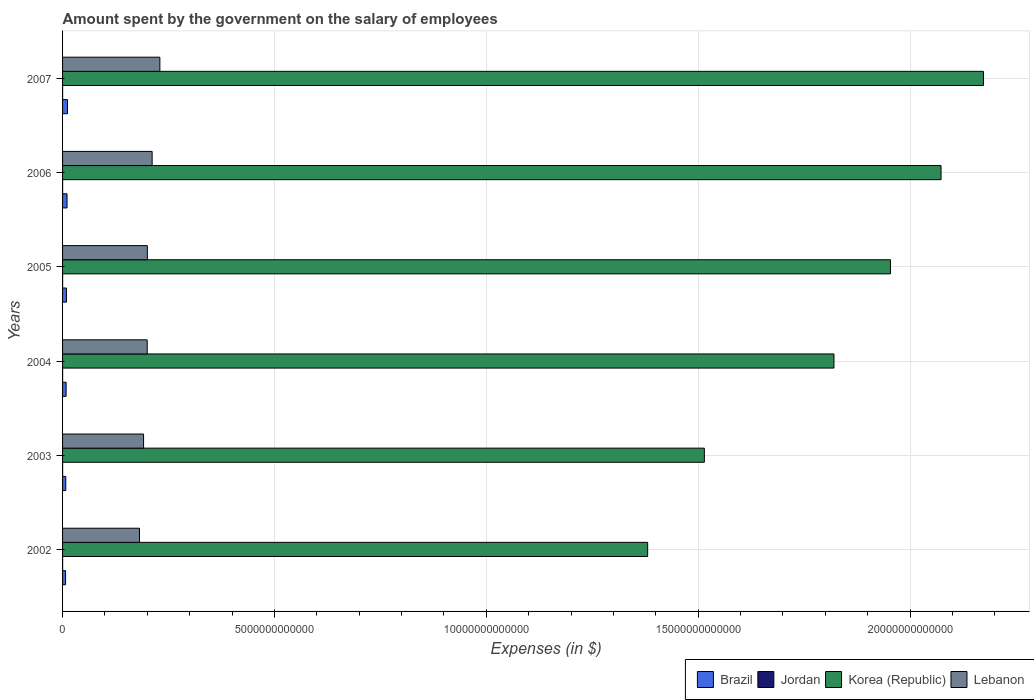How many different coloured bars are there?
Provide a short and direct response. 4. How many groups of bars are there?
Keep it short and to the point. 6. Are the number of bars on each tick of the Y-axis equal?
Your response must be concise. Yes. How many bars are there on the 6th tick from the top?
Offer a very short reply. 4. How many bars are there on the 2nd tick from the bottom?
Offer a very short reply. 4. In how many cases, is the number of bars for a given year not equal to the number of legend labels?
Provide a short and direct response. 0. What is the amount spent on the salary of employees by the government in Korea (Republic) in 2007?
Your answer should be compact. 2.17e+13. Across all years, what is the maximum amount spent on the salary of employees by the government in Korea (Republic)?
Give a very brief answer. 2.17e+13. Across all years, what is the minimum amount spent on the salary of employees by the government in Jordan?
Make the answer very short. 1.07e+09. In which year was the amount spent on the salary of employees by the government in Brazil maximum?
Your answer should be very brief. 2007. What is the total amount spent on the salary of employees by the government in Brazil in the graph?
Offer a very short reply. 5.45e+11. What is the difference between the amount spent on the salary of employees by the government in Jordan in 2002 and that in 2007?
Provide a succinct answer. 2.23e+08. What is the difference between the amount spent on the salary of employees by the government in Korea (Republic) in 2005 and the amount spent on the salary of employees by the government in Lebanon in 2002?
Give a very brief answer. 1.77e+13. What is the average amount spent on the salary of employees by the government in Jordan per year?
Your response must be concise. 1.32e+09. In the year 2003, what is the difference between the amount spent on the salary of employees by the government in Jordan and amount spent on the salary of employees by the government in Korea (Republic)?
Provide a succinct answer. -1.51e+13. In how many years, is the amount spent on the salary of employees by the government in Brazil greater than 19000000000000 $?
Offer a terse response. 0. What is the ratio of the amount spent on the salary of employees by the government in Korea (Republic) in 2002 to that in 2003?
Give a very brief answer. 0.91. Is the difference between the amount spent on the salary of employees by the government in Jordan in 2003 and 2007 greater than the difference between the amount spent on the salary of employees by the government in Korea (Republic) in 2003 and 2007?
Provide a succinct answer. Yes. What is the difference between the highest and the second highest amount spent on the salary of employees by the government in Lebanon?
Offer a terse response. 1.83e+11. What is the difference between the highest and the lowest amount spent on the salary of employees by the government in Jordan?
Provide a succinct answer. 4.33e+08. Is the sum of the amount spent on the salary of employees by the government in Lebanon in 2003 and 2005 greater than the maximum amount spent on the salary of employees by the government in Korea (Republic) across all years?
Make the answer very short. No. What does the 4th bar from the bottom in 2002 represents?
Ensure brevity in your answer.  Lebanon. How many bars are there?
Make the answer very short. 24. Are all the bars in the graph horizontal?
Keep it short and to the point. Yes. What is the difference between two consecutive major ticks on the X-axis?
Your response must be concise. 5.00e+12. Are the values on the major ticks of X-axis written in scientific E-notation?
Make the answer very short. No. How are the legend labels stacked?
Ensure brevity in your answer.  Horizontal. What is the title of the graph?
Your response must be concise. Amount spent by the government on the salary of employees. Does "World" appear as one of the legend labels in the graph?
Keep it short and to the point. No. What is the label or title of the X-axis?
Give a very brief answer. Expenses (in $). What is the label or title of the Y-axis?
Offer a terse response. Years. What is the Expenses (in $) in Brazil in 2002?
Provide a short and direct response. 7.11e+1. What is the Expenses (in $) of Jordan in 2002?
Your answer should be very brief. 1.29e+09. What is the Expenses (in $) in Korea (Republic) in 2002?
Provide a short and direct response. 1.38e+13. What is the Expenses (in $) in Lebanon in 2002?
Your answer should be compact. 1.82e+12. What is the Expenses (in $) of Brazil in 2003?
Make the answer very short. 7.58e+1. What is the Expenses (in $) in Jordan in 2003?
Your answer should be compact. 1.44e+09. What is the Expenses (in $) in Korea (Republic) in 2003?
Ensure brevity in your answer.  1.51e+13. What is the Expenses (in $) of Lebanon in 2003?
Offer a terse response. 1.91e+12. What is the Expenses (in $) in Brazil in 2004?
Keep it short and to the point. 8.37e+1. What is the Expenses (in $) of Jordan in 2004?
Give a very brief answer. 1.50e+09. What is the Expenses (in $) of Korea (Republic) in 2004?
Make the answer very short. 1.82e+13. What is the Expenses (in $) of Lebanon in 2004?
Offer a very short reply. 2.00e+12. What is the Expenses (in $) of Brazil in 2005?
Make the answer very short. 9.22e+1. What is the Expenses (in $) in Jordan in 2005?
Ensure brevity in your answer.  1.25e+09. What is the Expenses (in $) in Korea (Republic) in 2005?
Offer a very short reply. 1.95e+13. What is the Expenses (in $) in Lebanon in 2005?
Offer a very short reply. 2.00e+12. What is the Expenses (in $) in Brazil in 2006?
Keep it short and to the point. 1.05e+11. What is the Expenses (in $) in Jordan in 2006?
Provide a short and direct response. 1.38e+09. What is the Expenses (in $) of Korea (Republic) in 2006?
Offer a very short reply. 2.07e+13. What is the Expenses (in $) of Lebanon in 2006?
Provide a short and direct response. 2.11e+12. What is the Expenses (in $) in Brazil in 2007?
Offer a very short reply. 1.16e+11. What is the Expenses (in $) in Jordan in 2007?
Your answer should be compact. 1.07e+09. What is the Expenses (in $) of Korea (Republic) in 2007?
Provide a short and direct response. 2.17e+13. What is the Expenses (in $) of Lebanon in 2007?
Give a very brief answer. 2.30e+12. Across all years, what is the maximum Expenses (in $) of Brazil?
Offer a terse response. 1.16e+11. Across all years, what is the maximum Expenses (in $) of Jordan?
Ensure brevity in your answer.  1.50e+09. Across all years, what is the maximum Expenses (in $) of Korea (Republic)?
Provide a short and direct response. 2.17e+13. Across all years, what is the maximum Expenses (in $) of Lebanon?
Offer a very short reply. 2.30e+12. Across all years, what is the minimum Expenses (in $) of Brazil?
Give a very brief answer. 7.11e+1. Across all years, what is the minimum Expenses (in $) in Jordan?
Your answer should be compact. 1.07e+09. Across all years, what is the minimum Expenses (in $) in Korea (Republic)?
Your answer should be compact. 1.38e+13. Across all years, what is the minimum Expenses (in $) in Lebanon?
Offer a very short reply. 1.82e+12. What is the total Expenses (in $) in Brazil in the graph?
Give a very brief answer. 5.45e+11. What is the total Expenses (in $) of Jordan in the graph?
Your answer should be very brief. 7.93e+09. What is the total Expenses (in $) in Korea (Republic) in the graph?
Provide a short and direct response. 1.09e+14. What is the total Expenses (in $) of Lebanon in the graph?
Your response must be concise. 1.21e+13. What is the difference between the Expenses (in $) in Brazil in 2002 and that in 2003?
Offer a very short reply. -4.75e+09. What is the difference between the Expenses (in $) of Jordan in 2002 and that in 2003?
Make the answer very short. -1.46e+08. What is the difference between the Expenses (in $) in Korea (Republic) in 2002 and that in 2003?
Offer a very short reply. -1.34e+12. What is the difference between the Expenses (in $) in Lebanon in 2002 and that in 2003?
Offer a very short reply. -9.67e+1. What is the difference between the Expenses (in $) in Brazil in 2002 and that in 2004?
Ensure brevity in your answer.  -1.26e+1. What is the difference between the Expenses (in $) of Jordan in 2002 and that in 2004?
Your answer should be compact. -2.10e+08. What is the difference between the Expenses (in $) of Korea (Republic) in 2002 and that in 2004?
Your answer should be compact. -4.40e+12. What is the difference between the Expenses (in $) of Lebanon in 2002 and that in 2004?
Ensure brevity in your answer.  -1.82e+11. What is the difference between the Expenses (in $) in Brazil in 2002 and that in 2005?
Provide a succinct answer. -2.11e+1. What is the difference between the Expenses (in $) of Jordan in 2002 and that in 2005?
Provide a succinct answer. 3.66e+07. What is the difference between the Expenses (in $) in Korea (Republic) in 2002 and that in 2005?
Offer a terse response. -5.73e+12. What is the difference between the Expenses (in $) of Lebanon in 2002 and that in 2005?
Ensure brevity in your answer.  -1.86e+11. What is the difference between the Expenses (in $) of Brazil in 2002 and that in 2006?
Your answer should be very brief. -3.44e+1. What is the difference between the Expenses (in $) in Jordan in 2002 and that in 2006?
Ensure brevity in your answer.  -9.21e+07. What is the difference between the Expenses (in $) of Korea (Republic) in 2002 and that in 2006?
Provide a succinct answer. -6.92e+12. What is the difference between the Expenses (in $) in Lebanon in 2002 and that in 2006?
Your answer should be very brief. -2.99e+11. What is the difference between the Expenses (in $) in Brazil in 2002 and that in 2007?
Ensure brevity in your answer.  -4.53e+1. What is the difference between the Expenses (in $) in Jordan in 2002 and that in 2007?
Your response must be concise. 2.23e+08. What is the difference between the Expenses (in $) of Korea (Republic) in 2002 and that in 2007?
Your answer should be compact. -7.92e+12. What is the difference between the Expenses (in $) of Lebanon in 2002 and that in 2007?
Your response must be concise. -4.81e+11. What is the difference between the Expenses (in $) of Brazil in 2003 and that in 2004?
Offer a very short reply. -7.81e+09. What is the difference between the Expenses (in $) in Jordan in 2003 and that in 2004?
Your response must be concise. -6.46e+07. What is the difference between the Expenses (in $) of Korea (Republic) in 2003 and that in 2004?
Keep it short and to the point. -3.06e+12. What is the difference between the Expenses (in $) in Lebanon in 2003 and that in 2004?
Offer a terse response. -8.57e+1. What is the difference between the Expenses (in $) of Brazil in 2003 and that in 2005?
Provide a short and direct response. -1.64e+1. What is the difference between the Expenses (in $) in Jordan in 2003 and that in 2005?
Give a very brief answer. 1.82e+08. What is the difference between the Expenses (in $) in Korea (Republic) in 2003 and that in 2005?
Make the answer very short. -4.39e+12. What is the difference between the Expenses (in $) in Lebanon in 2003 and that in 2005?
Keep it short and to the point. -8.92e+1. What is the difference between the Expenses (in $) in Brazil in 2003 and that in 2006?
Ensure brevity in your answer.  -2.97e+1. What is the difference between the Expenses (in $) in Jordan in 2003 and that in 2006?
Ensure brevity in your answer.  5.34e+07. What is the difference between the Expenses (in $) of Korea (Republic) in 2003 and that in 2006?
Keep it short and to the point. -5.59e+12. What is the difference between the Expenses (in $) of Lebanon in 2003 and that in 2006?
Your answer should be compact. -2.02e+11. What is the difference between the Expenses (in $) in Brazil in 2003 and that in 2007?
Your answer should be compact. -4.05e+1. What is the difference between the Expenses (in $) in Jordan in 2003 and that in 2007?
Provide a short and direct response. 3.69e+08. What is the difference between the Expenses (in $) in Korea (Republic) in 2003 and that in 2007?
Keep it short and to the point. -6.59e+12. What is the difference between the Expenses (in $) of Lebanon in 2003 and that in 2007?
Provide a short and direct response. -3.85e+11. What is the difference between the Expenses (in $) of Brazil in 2004 and that in 2005?
Keep it short and to the point. -8.57e+09. What is the difference between the Expenses (in $) of Jordan in 2004 and that in 2005?
Make the answer very short. 2.47e+08. What is the difference between the Expenses (in $) in Korea (Republic) in 2004 and that in 2005?
Your answer should be compact. -1.33e+12. What is the difference between the Expenses (in $) in Lebanon in 2004 and that in 2005?
Your answer should be compact. -3.43e+09. What is the difference between the Expenses (in $) of Brazil in 2004 and that in 2006?
Your answer should be very brief. -2.18e+1. What is the difference between the Expenses (in $) in Jordan in 2004 and that in 2006?
Offer a very short reply. 1.18e+08. What is the difference between the Expenses (in $) of Korea (Republic) in 2004 and that in 2006?
Offer a very short reply. -2.53e+12. What is the difference between the Expenses (in $) of Lebanon in 2004 and that in 2006?
Ensure brevity in your answer.  -1.16e+11. What is the difference between the Expenses (in $) in Brazil in 2004 and that in 2007?
Your answer should be very brief. -3.27e+1. What is the difference between the Expenses (in $) in Jordan in 2004 and that in 2007?
Ensure brevity in your answer.  4.33e+08. What is the difference between the Expenses (in $) in Korea (Republic) in 2004 and that in 2007?
Ensure brevity in your answer.  -3.53e+12. What is the difference between the Expenses (in $) in Lebanon in 2004 and that in 2007?
Ensure brevity in your answer.  -2.99e+11. What is the difference between the Expenses (in $) of Brazil in 2005 and that in 2006?
Your answer should be compact. -1.33e+1. What is the difference between the Expenses (in $) in Jordan in 2005 and that in 2006?
Your response must be concise. -1.29e+08. What is the difference between the Expenses (in $) of Korea (Republic) in 2005 and that in 2006?
Offer a very short reply. -1.19e+12. What is the difference between the Expenses (in $) in Lebanon in 2005 and that in 2006?
Make the answer very short. -1.13e+11. What is the difference between the Expenses (in $) of Brazil in 2005 and that in 2007?
Offer a very short reply. -2.41e+1. What is the difference between the Expenses (in $) in Jordan in 2005 and that in 2007?
Your answer should be compact. 1.86e+08. What is the difference between the Expenses (in $) of Korea (Republic) in 2005 and that in 2007?
Your response must be concise. -2.19e+12. What is the difference between the Expenses (in $) of Lebanon in 2005 and that in 2007?
Your answer should be compact. -2.96e+11. What is the difference between the Expenses (in $) of Brazil in 2006 and that in 2007?
Make the answer very short. -1.09e+1. What is the difference between the Expenses (in $) in Jordan in 2006 and that in 2007?
Give a very brief answer. 3.15e+08. What is the difference between the Expenses (in $) of Korea (Republic) in 2006 and that in 2007?
Provide a succinct answer. -1.00e+12. What is the difference between the Expenses (in $) of Lebanon in 2006 and that in 2007?
Keep it short and to the point. -1.83e+11. What is the difference between the Expenses (in $) of Brazil in 2002 and the Expenses (in $) of Jordan in 2003?
Provide a succinct answer. 6.97e+1. What is the difference between the Expenses (in $) in Brazil in 2002 and the Expenses (in $) in Korea (Republic) in 2003?
Make the answer very short. -1.51e+13. What is the difference between the Expenses (in $) in Brazil in 2002 and the Expenses (in $) in Lebanon in 2003?
Offer a very short reply. -1.84e+12. What is the difference between the Expenses (in $) in Jordan in 2002 and the Expenses (in $) in Korea (Republic) in 2003?
Your answer should be compact. -1.51e+13. What is the difference between the Expenses (in $) of Jordan in 2002 and the Expenses (in $) of Lebanon in 2003?
Give a very brief answer. -1.91e+12. What is the difference between the Expenses (in $) in Korea (Republic) in 2002 and the Expenses (in $) in Lebanon in 2003?
Provide a succinct answer. 1.19e+13. What is the difference between the Expenses (in $) in Brazil in 2002 and the Expenses (in $) in Jordan in 2004?
Make the answer very short. 6.96e+1. What is the difference between the Expenses (in $) in Brazil in 2002 and the Expenses (in $) in Korea (Republic) in 2004?
Give a very brief answer. -1.81e+13. What is the difference between the Expenses (in $) in Brazil in 2002 and the Expenses (in $) in Lebanon in 2004?
Your answer should be very brief. -1.93e+12. What is the difference between the Expenses (in $) in Jordan in 2002 and the Expenses (in $) in Korea (Republic) in 2004?
Make the answer very short. -1.82e+13. What is the difference between the Expenses (in $) of Jordan in 2002 and the Expenses (in $) of Lebanon in 2004?
Offer a very short reply. -2.00e+12. What is the difference between the Expenses (in $) in Korea (Republic) in 2002 and the Expenses (in $) in Lebanon in 2004?
Offer a very short reply. 1.18e+13. What is the difference between the Expenses (in $) of Brazil in 2002 and the Expenses (in $) of Jordan in 2005?
Make the answer very short. 6.98e+1. What is the difference between the Expenses (in $) in Brazil in 2002 and the Expenses (in $) in Korea (Republic) in 2005?
Your response must be concise. -1.95e+13. What is the difference between the Expenses (in $) in Brazil in 2002 and the Expenses (in $) in Lebanon in 2005?
Make the answer very short. -1.93e+12. What is the difference between the Expenses (in $) of Jordan in 2002 and the Expenses (in $) of Korea (Republic) in 2005?
Provide a succinct answer. -1.95e+13. What is the difference between the Expenses (in $) in Jordan in 2002 and the Expenses (in $) in Lebanon in 2005?
Ensure brevity in your answer.  -2.00e+12. What is the difference between the Expenses (in $) of Korea (Republic) in 2002 and the Expenses (in $) of Lebanon in 2005?
Provide a short and direct response. 1.18e+13. What is the difference between the Expenses (in $) of Brazil in 2002 and the Expenses (in $) of Jordan in 2006?
Your answer should be very brief. 6.97e+1. What is the difference between the Expenses (in $) of Brazil in 2002 and the Expenses (in $) of Korea (Republic) in 2006?
Offer a very short reply. -2.07e+13. What is the difference between the Expenses (in $) of Brazil in 2002 and the Expenses (in $) of Lebanon in 2006?
Your answer should be very brief. -2.04e+12. What is the difference between the Expenses (in $) in Jordan in 2002 and the Expenses (in $) in Korea (Republic) in 2006?
Provide a short and direct response. -2.07e+13. What is the difference between the Expenses (in $) in Jordan in 2002 and the Expenses (in $) in Lebanon in 2006?
Provide a short and direct response. -2.11e+12. What is the difference between the Expenses (in $) in Korea (Republic) in 2002 and the Expenses (in $) in Lebanon in 2006?
Your answer should be very brief. 1.17e+13. What is the difference between the Expenses (in $) in Brazil in 2002 and the Expenses (in $) in Jordan in 2007?
Provide a succinct answer. 7.00e+1. What is the difference between the Expenses (in $) of Brazil in 2002 and the Expenses (in $) of Korea (Republic) in 2007?
Ensure brevity in your answer.  -2.17e+13. What is the difference between the Expenses (in $) of Brazil in 2002 and the Expenses (in $) of Lebanon in 2007?
Your answer should be compact. -2.23e+12. What is the difference between the Expenses (in $) of Jordan in 2002 and the Expenses (in $) of Korea (Republic) in 2007?
Your response must be concise. -2.17e+13. What is the difference between the Expenses (in $) in Jordan in 2002 and the Expenses (in $) in Lebanon in 2007?
Your response must be concise. -2.30e+12. What is the difference between the Expenses (in $) in Korea (Republic) in 2002 and the Expenses (in $) in Lebanon in 2007?
Ensure brevity in your answer.  1.15e+13. What is the difference between the Expenses (in $) of Brazil in 2003 and the Expenses (in $) of Jordan in 2004?
Give a very brief answer. 7.43e+1. What is the difference between the Expenses (in $) of Brazil in 2003 and the Expenses (in $) of Korea (Republic) in 2004?
Provide a succinct answer. -1.81e+13. What is the difference between the Expenses (in $) in Brazil in 2003 and the Expenses (in $) in Lebanon in 2004?
Give a very brief answer. -1.92e+12. What is the difference between the Expenses (in $) in Jordan in 2003 and the Expenses (in $) in Korea (Republic) in 2004?
Your answer should be compact. -1.82e+13. What is the difference between the Expenses (in $) of Jordan in 2003 and the Expenses (in $) of Lebanon in 2004?
Provide a succinct answer. -2.00e+12. What is the difference between the Expenses (in $) of Korea (Republic) in 2003 and the Expenses (in $) of Lebanon in 2004?
Offer a very short reply. 1.31e+13. What is the difference between the Expenses (in $) in Brazil in 2003 and the Expenses (in $) in Jordan in 2005?
Your response must be concise. 7.46e+1. What is the difference between the Expenses (in $) of Brazil in 2003 and the Expenses (in $) of Korea (Republic) in 2005?
Offer a very short reply. -1.95e+13. What is the difference between the Expenses (in $) in Brazil in 2003 and the Expenses (in $) in Lebanon in 2005?
Give a very brief answer. -1.93e+12. What is the difference between the Expenses (in $) of Jordan in 2003 and the Expenses (in $) of Korea (Republic) in 2005?
Offer a very short reply. -1.95e+13. What is the difference between the Expenses (in $) in Jordan in 2003 and the Expenses (in $) in Lebanon in 2005?
Your response must be concise. -2.00e+12. What is the difference between the Expenses (in $) of Korea (Republic) in 2003 and the Expenses (in $) of Lebanon in 2005?
Your response must be concise. 1.31e+13. What is the difference between the Expenses (in $) of Brazil in 2003 and the Expenses (in $) of Jordan in 2006?
Your answer should be compact. 7.45e+1. What is the difference between the Expenses (in $) in Brazil in 2003 and the Expenses (in $) in Korea (Republic) in 2006?
Provide a short and direct response. -2.07e+13. What is the difference between the Expenses (in $) in Brazil in 2003 and the Expenses (in $) in Lebanon in 2006?
Give a very brief answer. -2.04e+12. What is the difference between the Expenses (in $) in Jordan in 2003 and the Expenses (in $) in Korea (Republic) in 2006?
Your answer should be compact. -2.07e+13. What is the difference between the Expenses (in $) of Jordan in 2003 and the Expenses (in $) of Lebanon in 2006?
Make the answer very short. -2.11e+12. What is the difference between the Expenses (in $) of Korea (Republic) in 2003 and the Expenses (in $) of Lebanon in 2006?
Offer a very short reply. 1.30e+13. What is the difference between the Expenses (in $) of Brazil in 2003 and the Expenses (in $) of Jordan in 2007?
Your response must be concise. 7.48e+1. What is the difference between the Expenses (in $) in Brazil in 2003 and the Expenses (in $) in Korea (Republic) in 2007?
Your answer should be very brief. -2.17e+13. What is the difference between the Expenses (in $) in Brazil in 2003 and the Expenses (in $) in Lebanon in 2007?
Offer a very short reply. -2.22e+12. What is the difference between the Expenses (in $) in Jordan in 2003 and the Expenses (in $) in Korea (Republic) in 2007?
Give a very brief answer. -2.17e+13. What is the difference between the Expenses (in $) of Jordan in 2003 and the Expenses (in $) of Lebanon in 2007?
Provide a succinct answer. -2.30e+12. What is the difference between the Expenses (in $) of Korea (Republic) in 2003 and the Expenses (in $) of Lebanon in 2007?
Ensure brevity in your answer.  1.28e+13. What is the difference between the Expenses (in $) of Brazil in 2004 and the Expenses (in $) of Jordan in 2005?
Offer a very short reply. 8.24e+1. What is the difference between the Expenses (in $) of Brazil in 2004 and the Expenses (in $) of Korea (Republic) in 2005?
Your answer should be compact. -1.95e+13. What is the difference between the Expenses (in $) of Brazil in 2004 and the Expenses (in $) of Lebanon in 2005?
Keep it short and to the point. -1.92e+12. What is the difference between the Expenses (in $) of Jordan in 2004 and the Expenses (in $) of Korea (Republic) in 2005?
Ensure brevity in your answer.  -1.95e+13. What is the difference between the Expenses (in $) of Jordan in 2004 and the Expenses (in $) of Lebanon in 2005?
Your answer should be compact. -2.00e+12. What is the difference between the Expenses (in $) of Korea (Republic) in 2004 and the Expenses (in $) of Lebanon in 2005?
Your response must be concise. 1.62e+13. What is the difference between the Expenses (in $) of Brazil in 2004 and the Expenses (in $) of Jordan in 2006?
Give a very brief answer. 8.23e+1. What is the difference between the Expenses (in $) of Brazil in 2004 and the Expenses (in $) of Korea (Republic) in 2006?
Your response must be concise. -2.06e+13. What is the difference between the Expenses (in $) in Brazil in 2004 and the Expenses (in $) in Lebanon in 2006?
Your answer should be compact. -2.03e+12. What is the difference between the Expenses (in $) of Jordan in 2004 and the Expenses (in $) of Korea (Republic) in 2006?
Ensure brevity in your answer.  -2.07e+13. What is the difference between the Expenses (in $) in Jordan in 2004 and the Expenses (in $) in Lebanon in 2006?
Offer a terse response. -2.11e+12. What is the difference between the Expenses (in $) in Korea (Republic) in 2004 and the Expenses (in $) in Lebanon in 2006?
Offer a terse response. 1.61e+13. What is the difference between the Expenses (in $) of Brazil in 2004 and the Expenses (in $) of Jordan in 2007?
Your response must be concise. 8.26e+1. What is the difference between the Expenses (in $) of Brazil in 2004 and the Expenses (in $) of Korea (Republic) in 2007?
Your response must be concise. -2.16e+13. What is the difference between the Expenses (in $) of Brazil in 2004 and the Expenses (in $) of Lebanon in 2007?
Your response must be concise. -2.21e+12. What is the difference between the Expenses (in $) in Jordan in 2004 and the Expenses (in $) in Korea (Republic) in 2007?
Your response must be concise. -2.17e+13. What is the difference between the Expenses (in $) in Jordan in 2004 and the Expenses (in $) in Lebanon in 2007?
Ensure brevity in your answer.  -2.30e+12. What is the difference between the Expenses (in $) in Korea (Republic) in 2004 and the Expenses (in $) in Lebanon in 2007?
Offer a terse response. 1.59e+13. What is the difference between the Expenses (in $) in Brazil in 2005 and the Expenses (in $) in Jordan in 2006?
Keep it short and to the point. 9.08e+1. What is the difference between the Expenses (in $) of Brazil in 2005 and the Expenses (in $) of Korea (Republic) in 2006?
Your answer should be compact. -2.06e+13. What is the difference between the Expenses (in $) of Brazil in 2005 and the Expenses (in $) of Lebanon in 2006?
Your response must be concise. -2.02e+12. What is the difference between the Expenses (in $) in Jordan in 2005 and the Expenses (in $) in Korea (Republic) in 2006?
Provide a succinct answer. -2.07e+13. What is the difference between the Expenses (in $) in Jordan in 2005 and the Expenses (in $) in Lebanon in 2006?
Make the answer very short. -2.11e+12. What is the difference between the Expenses (in $) of Korea (Republic) in 2005 and the Expenses (in $) of Lebanon in 2006?
Your response must be concise. 1.74e+13. What is the difference between the Expenses (in $) of Brazil in 2005 and the Expenses (in $) of Jordan in 2007?
Offer a very short reply. 9.12e+1. What is the difference between the Expenses (in $) in Brazil in 2005 and the Expenses (in $) in Korea (Republic) in 2007?
Provide a short and direct response. -2.16e+13. What is the difference between the Expenses (in $) of Brazil in 2005 and the Expenses (in $) of Lebanon in 2007?
Keep it short and to the point. -2.20e+12. What is the difference between the Expenses (in $) of Jordan in 2005 and the Expenses (in $) of Korea (Republic) in 2007?
Make the answer very short. -2.17e+13. What is the difference between the Expenses (in $) in Jordan in 2005 and the Expenses (in $) in Lebanon in 2007?
Make the answer very short. -2.30e+12. What is the difference between the Expenses (in $) of Korea (Republic) in 2005 and the Expenses (in $) of Lebanon in 2007?
Provide a short and direct response. 1.72e+13. What is the difference between the Expenses (in $) in Brazil in 2006 and the Expenses (in $) in Jordan in 2007?
Give a very brief answer. 1.04e+11. What is the difference between the Expenses (in $) of Brazil in 2006 and the Expenses (in $) of Korea (Republic) in 2007?
Give a very brief answer. -2.16e+13. What is the difference between the Expenses (in $) in Brazil in 2006 and the Expenses (in $) in Lebanon in 2007?
Ensure brevity in your answer.  -2.19e+12. What is the difference between the Expenses (in $) in Jordan in 2006 and the Expenses (in $) in Korea (Republic) in 2007?
Provide a succinct answer. -2.17e+13. What is the difference between the Expenses (in $) in Jordan in 2006 and the Expenses (in $) in Lebanon in 2007?
Your answer should be very brief. -2.30e+12. What is the difference between the Expenses (in $) of Korea (Republic) in 2006 and the Expenses (in $) of Lebanon in 2007?
Ensure brevity in your answer.  1.84e+13. What is the average Expenses (in $) of Brazil per year?
Your response must be concise. 9.08e+1. What is the average Expenses (in $) in Jordan per year?
Ensure brevity in your answer.  1.32e+09. What is the average Expenses (in $) of Korea (Republic) per year?
Ensure brevity in your answer.  1.82e+13. What is the average Expenses (in $) in Lebanon per year?
Your answer should be compact. 2.02e+12. In the year 2002, what is the difference between the Expenses (in $) of Brazil and Expenses (in $) of Jordan?
Offer a very short reply. 6.98e+1. In the year 2002, what is the difference between the Expenses (in $) in Brazil and Expenses (in $) in Korea (Republic)?
Make the answer very short. -1.37e+13. In the year 2002, what is the difference between the Expenses (in $) in Brazil and Expenses (in $) in Lebanon?
Your answer should be very brief. -1.74e+12. In the year 2002, what is the difference between the Expenses (in $) of Jordan and Expenses (in $) of Korea (Republic)?
Provide a succinct answer. -1.38e+13. In the year 2002, what is the difference between the Expenses (in $) of Jordan and Expenses (in $) of Lebanon?
Provide a short and direct response. -1.81e+12. In the year 2002, what is the difference between the Expenses (in $) of Korea (Republic) and Expenses (in $) of Lebanon?
Your answer should be compact. 1.20e+13. In the year 2003, what is the difference between the Expenses (in $) in Brazil and Expenses (in $) in Jordan?
Provide a short and direct response. 7.44e+1. In the year 2003, what is the difference between the Expenses (in $) in Brazil and Expenses (in $) in Korea (Republic)?
Ensure brevity in your answer.  -1.51e+13. In the year 2003, what is the difference between the Expenses (in $) in Brazil and Expenses (in $) in Lebanon?
Offer a terse response. -1.84e+12. In the year 2003, what is the difference between the Expenses (in $) in Jordan and Expenses (in $) in Korea (Republic)?
Keep it short and to the point. -1.51e+13. In the year 2003, what is the difference between the Expenses (in $) in Jordan and Expenses (in $) in Lebanon?
Provide a succinct answer. -1.91e+12. In the year 2003, what is the difference between the Expenses (in $) in Korea (Republic) and Expenses (in $) in Lebanon?
Make the answer very short. 1.32e+13. In the year 2004, what is the difference between the Expenses (in $) in Brazil and Expenses (in $) in Jordan?
Your answer should be compact. 8.22e+1. In the year 2004, what is the difference between the Expenses (in $) of Brazil and Expenses (in $) of Korea (Republic)?
Offer a very short reply. -1.81e+13. In the year 2004, what is the difference between the Expenses (in $) in Brazil and Expenses (in $) in Lebanon?
Your answer should be very brief. -1.91e+12. In the year 2004, what is the difference between the Expenses (in $) of Jordan and Expenses (in $) of Korea (Republic)?
Keep it short and to the point. -1.82e+13. In the year 2004, what is the difference between the Expenses (in $) of Jordan and Expenses (in $) of Lebanon?
Provide a succinct answer. -2.00e+12. In the year 2004, what is the difference between the Expenses (in $) of Korea (Republic) and Expenses (in $) of Lebanon?
Your response must be concise. 1.62e+13. In the year 2005, what is the difference between the Expenses (in $) in Brazil and Expenses (in $) in Jordan?
Give a very brief answer. 9.10e+1. In the year 2005, what is the difference between the Expenses (in $) in Brazil and Expenses (in $) in Korea (Republic)?
Give a very brief answer. -1.94e+13. In the year 2005, what is the difference between the Expenses (in $) of Brazil and Expenses (in $) of Lebanon?
Provide a short and direct response. -1.91e+12. In the year 2005, what is the difference between the Expenses (in $) in Jordan and Expenses (in $) in Korea (Republic)?
Your answer should be compact. -1.95e+13. In the year 2005, what is the difference between the Expenses (in $) of Jordan and Expenses (in $) of Lebanon?
Make the answer very short. -2.00e+12. In the year 2005, what is the difference between the Expenses (in $) in Korea (Republic) and Expenses (in $) in Lebanon?
Offer a terse response. 1.75e+13. In the year 2006, what is the difference between the Expenses (in $) in Brazil and Expenses (in $) in Jordan?
Your answer should be compact. 1.04e+11. In the year 2006, what is the difference between the Expenses (in $) of Brazil and Expenses (in $) of Korea (Republic)?
Offer a very short reply. -2.06e+13. In the year 2006, what is the difference between the Expenses (in $) of Brazil and Expenses (in $) of Lebanon?
Provide a succinct answer. -2.01e+12. In the year 2006, what is the difference between the Expenses (in $) in Jordan and Expenses (in $) in Korea (Republic)?
Make the answer very short. -2.07e+13. In the year 2006, what is the difference between the Expenses (in $) of Jordan and Expenses (in $) of Lebanon?
Your answer should be very brief. -2.11e+12. In the year 2006, what is the difference between the Expenses (in $) in Korea (Republic) and Expenses (in $) in Lebanon?
Provide a succinct answer. 1.86e+13. In the year 2007, what is the difference between the Expenses (in $) of Brazil and Expenses (in $) of Jordan?
Give a very brief answer. 1.15e+11. In the year 2007, what is the difference between the Expenses (in $) in Brazil and Expenses (in $) in Korea (Republic)?
Provide a short and direct response. -2.16e+13. In the year 2007, what is the difference between the Expenses (in $) of Brazil and Expenses (in $) of Lebanon?
Make the answer very short. -2.18e+12. In the year 2007, what is the difference between the Expenses (in $) of Jordan and Expenses (in $) of Korea (Republic)?
Your response must be concise. -2.17e+13. In the year 2007, what is the difference between the Expenses (in $) in Jordan and Expenses (in $) in Lebanon?
Ensure brevity in your answer.  -2.30e+12. In the year 2007, what is the difference between the Expenses (in $) in Korea (Republic) and Expenses (in $) in Lebanon?
Give a very brief answer. 1.94e+13. What is the ratio of the Expenses (in $) in Brazil in 2002 to that in 2003?
Offer a terse response. 0.94. What is the ratio of the Expenses (in $) of Jordan in 2002 to that in 2003?
Your response must be concise. 0.9. What is the ratio of the Expenses (in $) in Korea (Republic) in 2002 to that in 2003?
Offer a very short reply. 0.91. What is the ratio of the Expenses (in $) of Lebanon in 2002 to that in 2003?
Your answer should be compact. 0.95. What is the ratio of the Expenses (in $) in Brazil in 2002 to that in 2004?
Ensure brevity in your answer.  0.85. What is the ratio of the Expenses (in $) in Jordan in 2002 to that in 2004?
Your answer should be compact. 0.86. What is the ratio of the Expenses (in $) in Korea (Republic) in 2002 to that in 2004?
Make the answer very short. 0.76. What is the ratio of the Expenses (in $) in Lebanon in 2002 to that in 2004?
Offer a terse response. 0.91. What is the ratio of the Expenses (in $) in Brazil in 2002 to that in 2005?
Provide a short and direct response. 0.77. What is the ratio of the Expenses (in $) in Jordan in 2002 to that in 2005?
Provide a succinct answer. 1.03. What is the ratio of the Expenses (in $) of Korea (Republic) in 2002 to that in 2005?
Ensure brevity in your answer.  0.71. What is the ratio of the Expenses (in $) of Lebanon in 2002 to that in 2005?
Offer a very short reply. 0.91. What is the ratio of the Expenses (in $) of Brazil in 2002 to that in 2006?
Your response must be concise. 0.67. What is the ratio of the Expenses (in $) of Jordan in 2002 to that in 2006?
Provide a succinct answer. 0.93. What is the ratio of the Expenses (in $) in Korea (Republic) in 2002 to that in 2006?
Keep it short and to the point. 0.67. What is the ratio of the Expenses (in $) in Lebanon in 2002 to that in 2006?
Give a very brief answer. 0.86. What is the ratio of the Expenses (in $) in Brazil in 2002 to that in 2007?
Give a very brief answer. 0.61. What is the ratio of the Expenses (in $) in Jordan in 2002 to that in 2007?
Keep it short and to the point. 1.21. What is the ratio of the Expenses (in $) in Korea (Republic) in 2002 to that in 2007?
Your response must be concise. 0.64. What is the ratio of the Expenses (in $) of Lebanon in 2002 to that in 2007?
Your answer should be compact. 0.79. What is the ratio of the Expenses (in $) of Brazil in 2003 to that in 2004?
Give a very brief answer. 0.91. What is the ratio of the Expenses (in $) in Jordan in 2003 to that in 2004?
Your answer should be compact. 0.96. What is the ratio of the Expenses (in $) in Korea (Republic) in 2003 to that in 2004?
Keep it short and to the point. 0.83. What is the ratio of the Expenses (in $) in Lebanon in 2003 to that in 2004?
Make the answer very short. 0.96. What is the ratio of the Expenses (in $) in Brazil in 2003 to that in 2005?
Keep it short and to the point. 0.82. What is the ratio of the Expenses (in $) in Jordan in 2003 to that in 2005?
Offer a terse response. 1.15. What is the ratio of the Expenses (in $) in Korea (Republic) in 2003 to that in 2005?
Provide a succinct answer. 0.78. What is the ratio of the Expenses (in $) of Lebanon in 2003 to that in 2005?
Provide a short and direct response. 0.96. What is the ratio of the Expenses (in $) in Brazil in 2003 to that in 2006?
Your response must be concise. 0.72. What is the ratio of the Expenses (in $) of Jordan in 2003 to that in 2006?
Offer a very short reply. 1.04. What is the ratio of the Expenses (in $) of Korea (Republic) in 2003 to that in 2006?
Make the answer very short. 0.73. What is the ratio of the Expenses (in $) in Lebanon in 2003 to that in 2006?
Give a very brief answer. 0.9. What is the ratio of the Expenses (in $) in Brazil in 2003 to that in 2007?
Your answer should be compact. 0.65. What is the ratio of the Expenses (in $) in Jordan in 2003 to that in 2007?
Ensure brevity in your answer.  1.35. What is the ratio of the Expenses (in $) of Korea (Republic) in 2003 to that in 2007?
Your answer should be very brief. 0.7. What is the ratio of the Expenses (in $) in Lebanon in 2003 to that in 2007?
Provide a short and direct response. 0.83. What is the ratio of the Expenses (in $) in Brazil in 2004 to that in 2005?
Provide a succinct answer. 0.91. What is the ratio of the Expenses (in $) of Jordan in 2004 to that in 2005?
Your answer should be compact. 1.2. What is the ratio of the Expenses (in $) in Korea (Republic) in 2004 to that in 2005?
Keep it short and to the point. 0.93. What is the ratio of the Expenses (in $) of Lebanon in 2004 to that in 2005?
Offer a very short reply. 1. What is the ratio of the Expenses (in $) in Brazil in 2004 to that in 2006?
Make the answer very short. 0.79. What is the ratio of the Expenses (in $) of Jordan in 2004 to that in 2006?
Offer a very short reply. 1.09. What is the ratio of the Expenses (in $) in Korea (Republic) in 2004 to that in 2006?
Your response must be concise. 0.88. What is the ratio of the Expenses (in $) of Lebanon in 2004 to that in 2006?
Your response must be concise. 0.94. What is the ratio of the Expenses (in $) of Brazil in 2004 to that in 2007?
Your answer should be compact. 0.72. What is the ratio of the Expenses (in $) of Jordan in 2004 to that in 2007?
Your response must be concise. 1.41. What is the ratio of the Expenses (in $) of Korea (Republic) in 2004 to that in 2007?
Your answer should be compact. 0.84. What is the ratio of the Expenses (in $) in Lebanon in 2004 to that in 2007?
Offer a terse response. 0.87. What is the ratio of the Expenses (in $) of Brazil in 2005 to that in 2006?
Give a very brief answer. 0.87. What is the ratio of the Expenses (in $) of Jordan in 2005 to that in 2006?
Your answer should be very brief. 0.91. What is the ratio of the Expenses (in $) of Korea (Republic) in 2005 to that in 2006?
Keep it short and to the point. 0.94. What is the ratio of the Expenses (in $) in Lebanon in 2005 to that in 2006?
Ensure brevity in your answer.  0.95. What is the ratio of the Expenses (in $) in Brazil in 2005 to that in 2007?
Provide a succinct answer. 0.79. What is the ratio of the Expenses (in $) of Jordan in 2005 to that in 2007?
Keep it short and to the point. 1.17. What is the ratio of the Expenses (in $) in Korea (Republic) in 2005 to that in 2007?
Offer a terse response. 0.9. What is the ratio of the Expenses (in $) of Lebanon in 2005 to that in 2007?
Ensure brevity in your answer.  0.87. What is the ratio of the Expenses (in $) of Brazil in 2006 to that in 2007?
Provide a short and direct response. 0.91. What is the ratio of the Expenses (in $) in Jordan in 2006 to that in 2007?
Offer a terse response. 1.3. What is the ratio of the Expenses (in $) of Korea (Republic) in 2006 to that in 2007?
Provide a succinct answer. 0.95. What is the ratio of the Expenses (in $) of Lebanon in 2006 to that in 2007?
Offer a very short reply. 0.92. What is the difference between the highest and the second highest Expenses (in $) of Brazil?
Your answer should be very brief. 1.09e+1. What is the difference between the highest and the second highest Expenses (in $) in Jordan?
Offer a terse response. 6.46e+07. What is the difference between the highest and the second highest Expenses (in $) in Korea (Republic)?
Your answer should be compact. 1.00e+12. What is the difference between the highest and the second highest Expenses (in $) in Lebanon?
Ensure brevity in your answer.  1.83e+11. What is the difference between the highest and the lowest Expenses (in $) of Brazil?
Your response must be concise. 4.53e+1. What is the difference between the highest and the lowest Expenses (in $) of Jordan?
Your answer should be very brief. 4.33e+08. What is the difference between the highest and the lowest Expenses (in $) of Korea (Republic)?
Keep it short and to the point. 7.92e+12. What is the difference between the highest and the lowest Expenses (in $) in Lebanon?
Ensure brevity in your answer.  4.81e+11. 